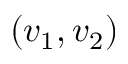<formula> <loc_0><loc_0><loc_500><loc_500>( v _ { 1 } , v _ { 2 } )</formula> 